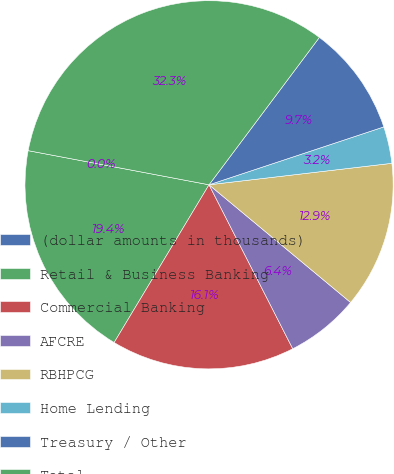Convert chart to OTSL. <chart><loc_0><loc_0><loc_500><loc_500><pie_chart><fcel>(dollar amounts in thousands)<fcel>Retail & Business Banking<fcel>Commercial Banking<fcel>AFCRE<fcel>RBHPCG<fcel>Home Lending<fcel>Treasury / Other<fcel>Total<nl><fcel>0.0%<fcel>19.35%<fcel>16.13%<fcel>6.45%<fcel>12.9%<fcel>3.23%<fcel>9.68%<fcel>32.26%<nl></chart> 